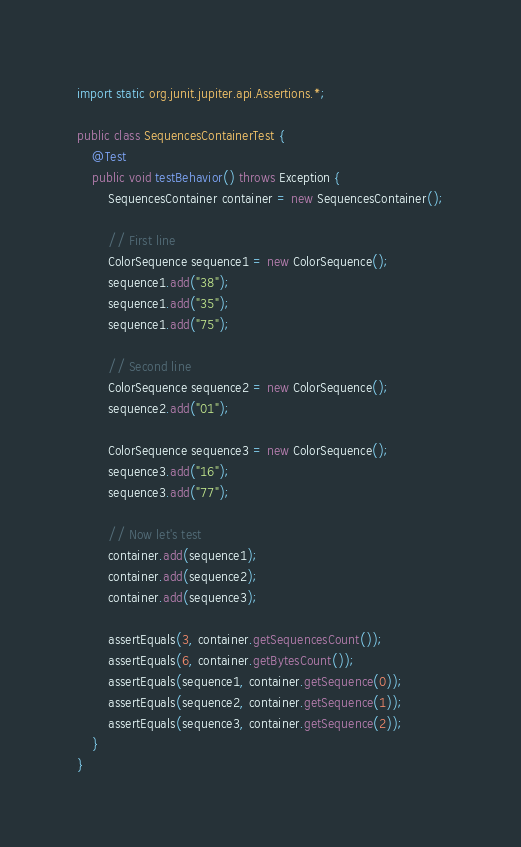Convert code to text. <code><loc_0><loc_0><loc_500><loc_500><_Java_>import static org.junit.jupiter.api.Assertions.*;

public class SequencesContainerTest {
    @Test
    public void testBehavior() throws Exception {
        SequencesContainer container = new SequencesContainer();

        // First line
        ColorSequence sequence1 = new ColorSequence();
        sequence1.add("38");
        sequence1.add("35");
        sequence1.add("75");

        // Second line
        ColorSequence sequence2 = new ColorSequence();
        sequence2.add("01");

        ColorSequence sequence3 = new ColorSequence();
        sequence3.add("16");
        sequence3.add("77");

        // Now let's test
        container.add(sequence1);
        container.add(sequence2);
        container.add(sequence3);

        assertEquals(3, container.getSequencesCount());
        assertEquals(6, container.getBytesCount());
        assertEquals(sequence1, container.getSequence(0));
        assertEquals(sequence2, container.getSequence(1));
        assertEquals(sequence3, container.getSequence(2));
    }
}
</code> 